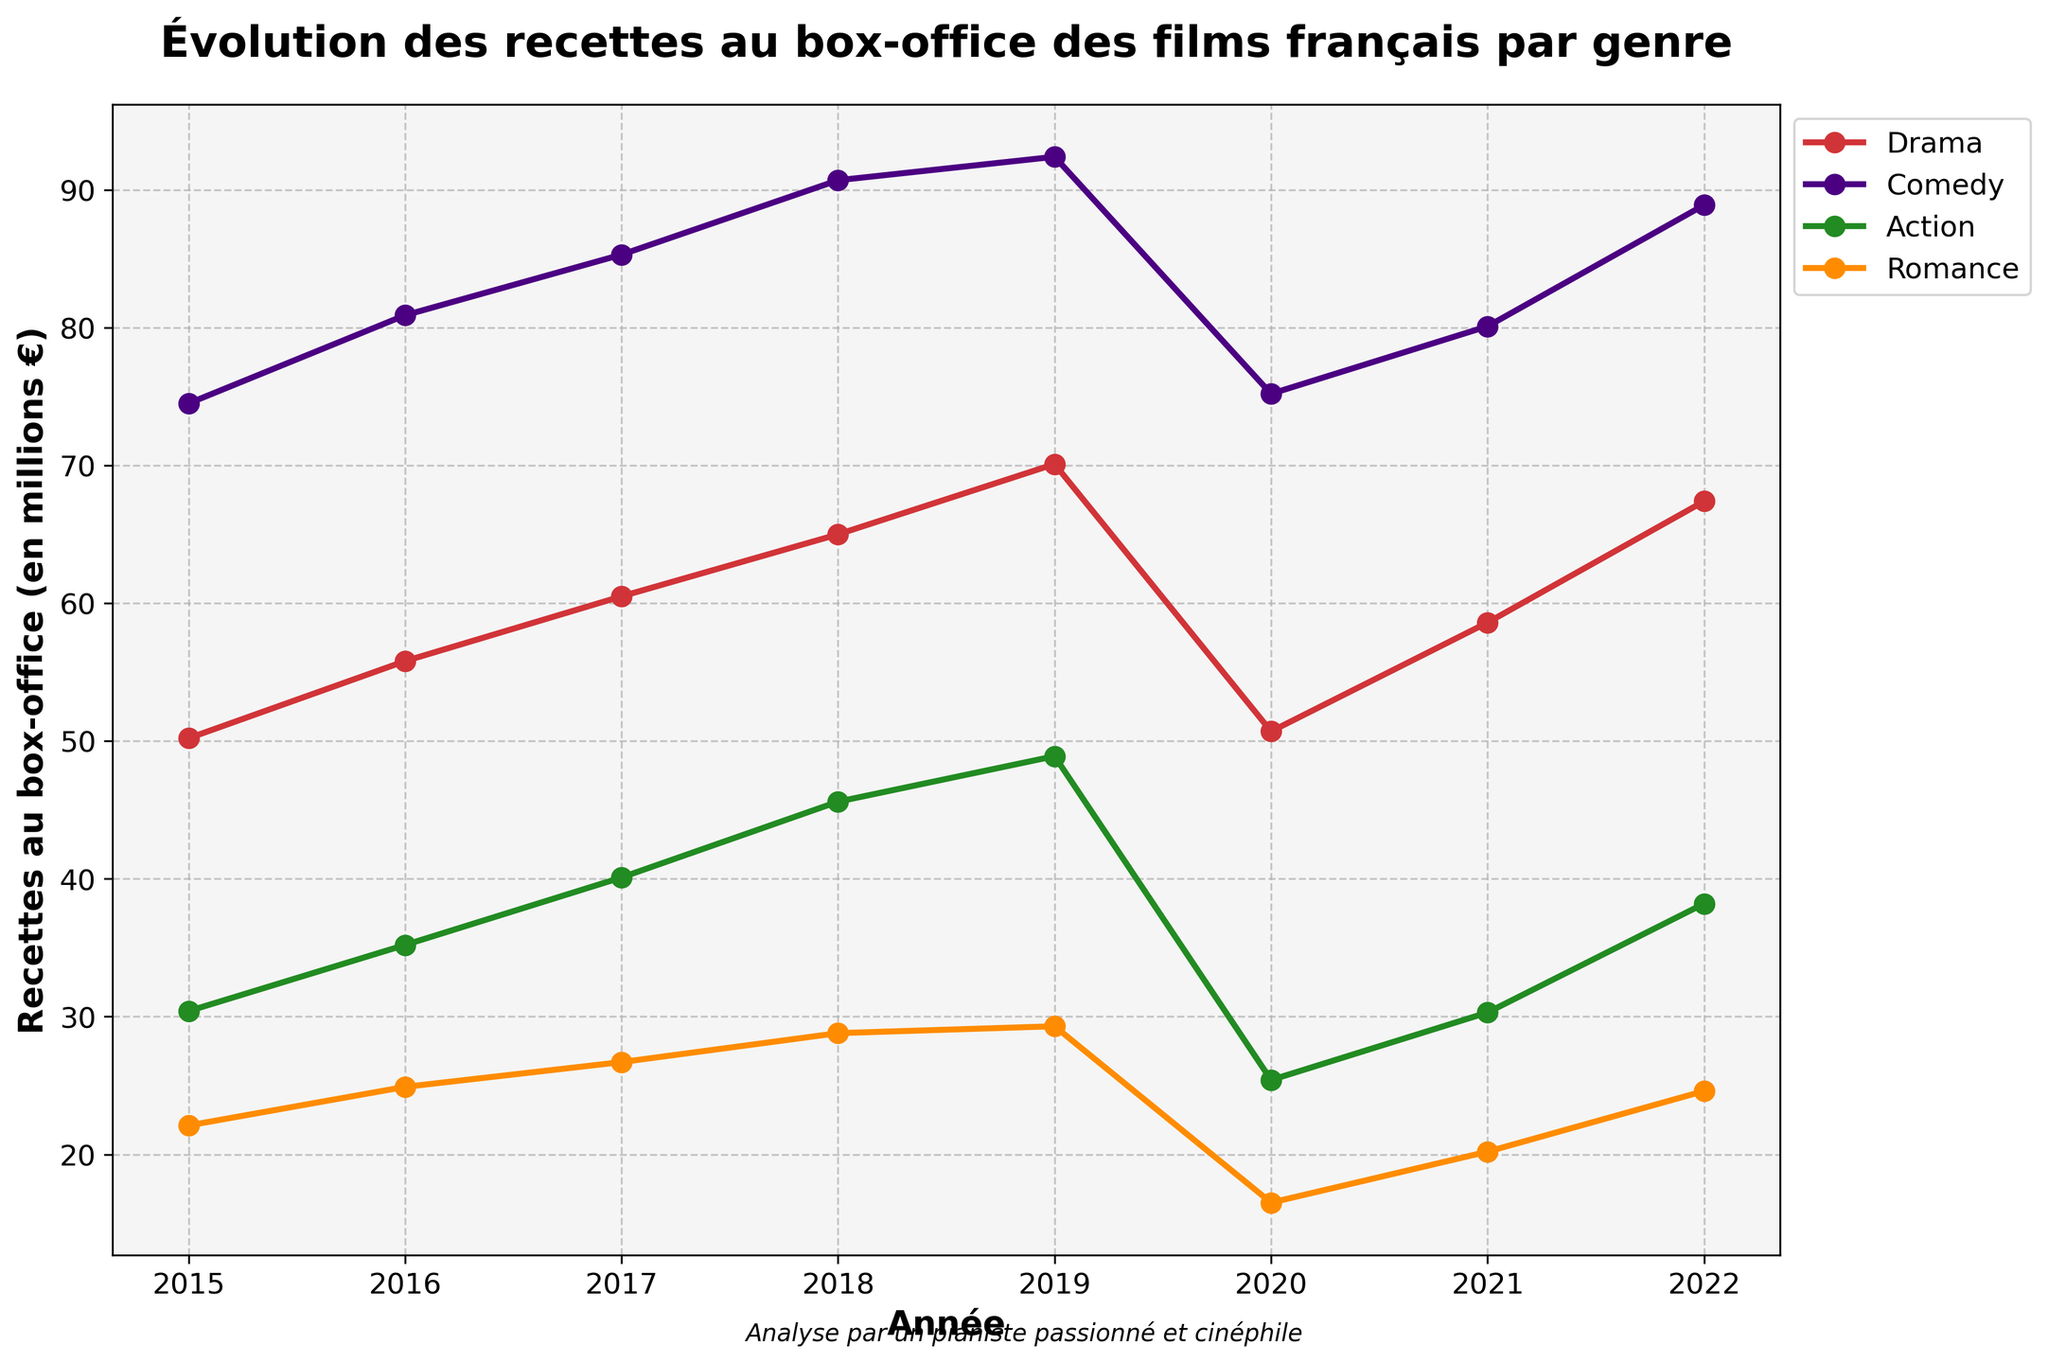How many genres are represented in the plot? The plot has lines representing different genres, and a legend indicating four different genres.
Answer: 4 What trend do you observe for the genre Comedy over the years? Observing the plot line for Comedy from 2015 to 2022 shows a general upward trend, with a dip in 2020.
Answer: Upward, with a dip in 2020 Which genre had the highest box office revenue for most of the years between 2015 and 2022? Checking the highest data points for each year from 2015 to 2022, Comedy consistently has the highest box office revenue except for 2020.
Answer: Comedy In which year did the Action genre have its peak box office revenue, and what was the amount? Observing the Action plot line, the peak appears in 2019 at 48.9 million euros.
Answer: 2019, 48.9 million euros What was the box office revenue for Romance and Comedy in 2020? Checking the plotted points for 2020, Romance has 16.5 million euros, and Comedy has 75.2 million euros.
Answer: Romance: 16.5 million euros, Comedy: 75.2 million euros What is the difference in box office revenue between the genres Drama and Action in 2022? In 2022, Drama has a box office revenue of 67.4 million euros, and Action has 38.2 million euros. The difference is calculated as 67.4 - 38.2.
Answer: 29.2 million euros Which genre shows the most variability in its box office revenue over the years? Observing the fluctuations, Comedy has the most noticeable changes, especially with the dip in 2020 and significant increases in other years.
Answer: Comedy How did the box office revenue for Drama change between 2019 and 2020? Drama's revenue in 2019 was 70.1 million euros, and it decreased to 50.7 million euros in 2020. The change is calculated as 70.1 - 50.7.
Answer: Decreased by 19.4 million euros What is the trend in box office revenue for Romance from 2020 to 2022? Observing the Romance plot line from 2020 to 2022, it shows an upward trend from 16.5 million euros in 2020 to 24.6 million euros in 2022.
Answer: Upward Between which consecutive years did Comedy show the greatest increase in box office revenue? Checking the Comedy line, the greatest increase occurs between 2015 and 2016, from 74.5 million euros to 80.9 million euros. The increase is 80.9 - 74.5.
Answer: 2015 to 2016, 6.4 million euros 